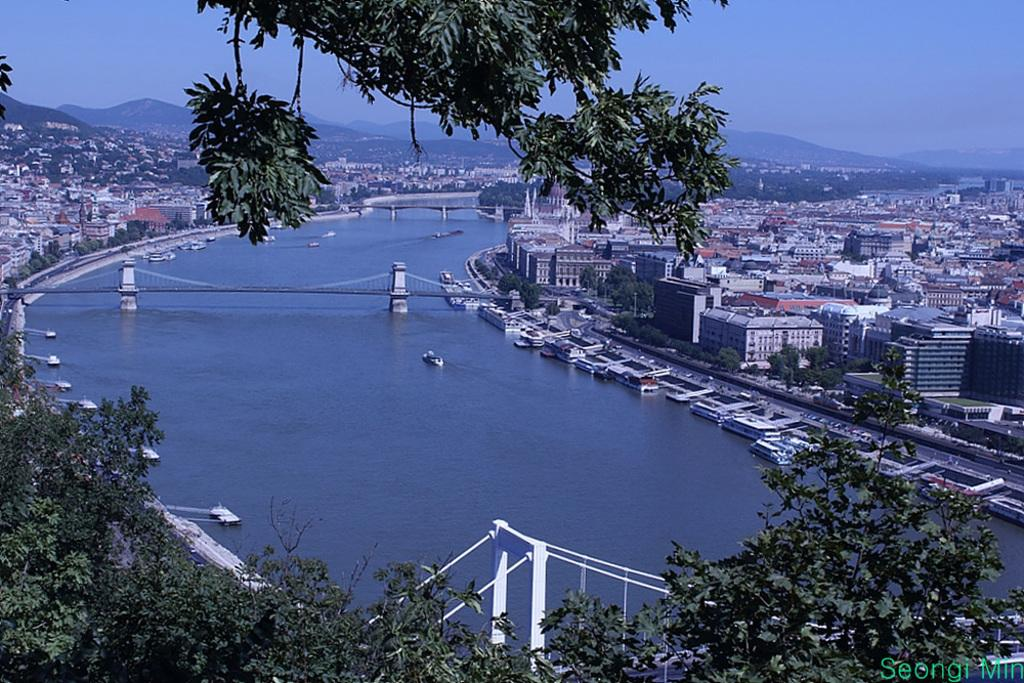What is in the water in the image? There are boats in the water in the image. What can be seen in the background of the image? There are buildings and trees with green color in the background. What is the color of the sky in the image? The sky is blue in color. How many boys are holding wool in the image? There are no boys or wool present in the image. 